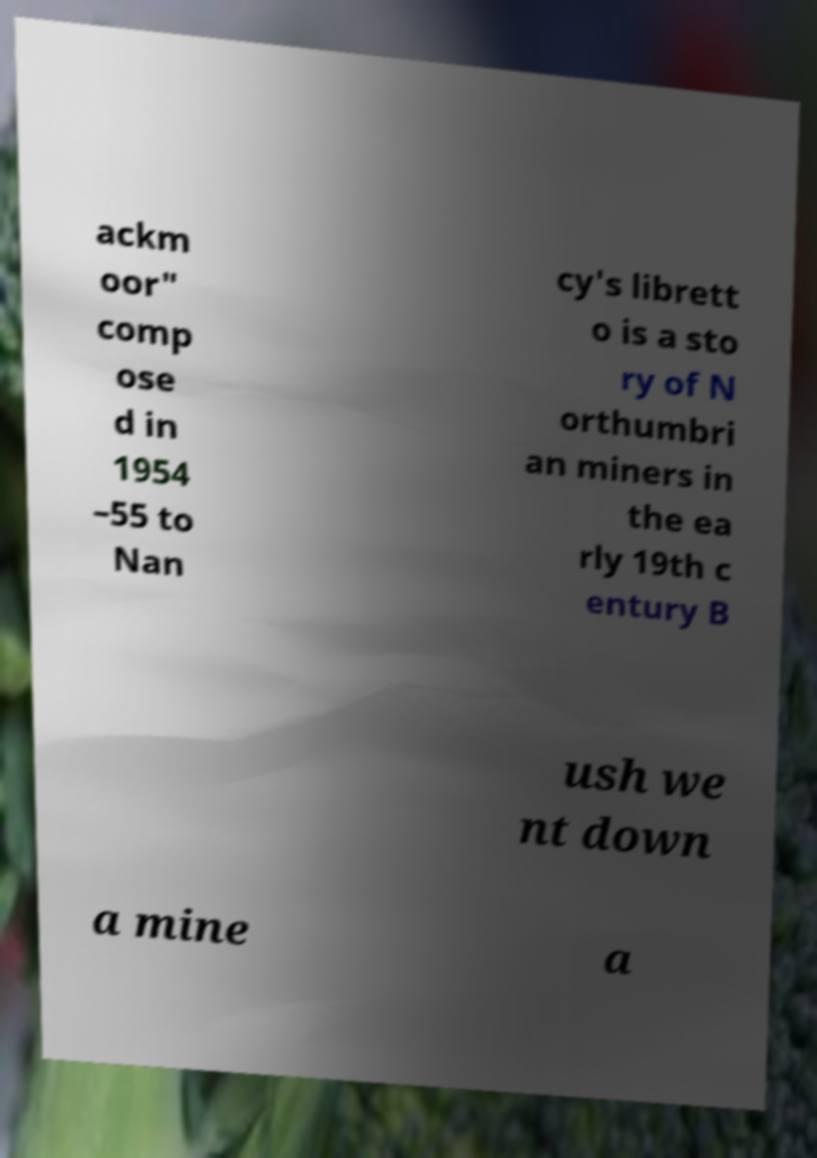I need the written content from this picture converted into text. Can you do that? ackm oor" comp ose d in 1954 –55 to Nan cy's librett o is a sto ry of N orthumbri an miners in the ea rly 19th c entury B ush we nt down a mine a 